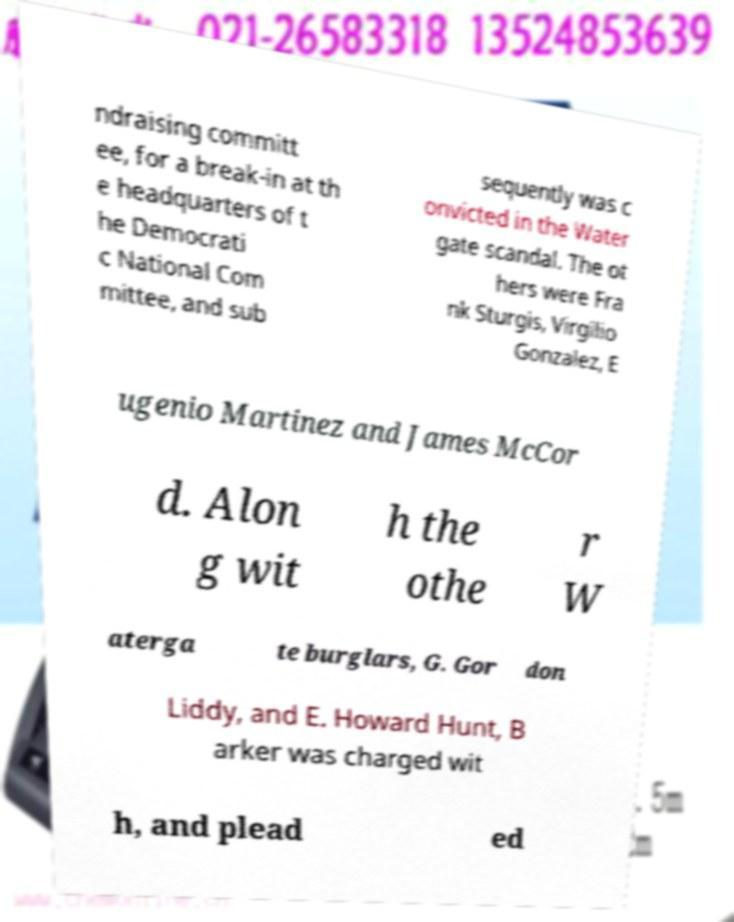Could you extract and type out the text from this image? ndraising committ ee, for a break-in at th e headquarters of t he Democrati c National Com mittee, and sub sequently was c onvicted in the Water gate scandal. The ot hers were Fra nk Sturgis, Virgilio Gonzalez, E ugenio Martinez and James McCor d. Alon g wit h the othe r W aterga te burglars, G. Gor don Liddy, and E. Howard Hunt, B arker was charged wit h, and plead ed 